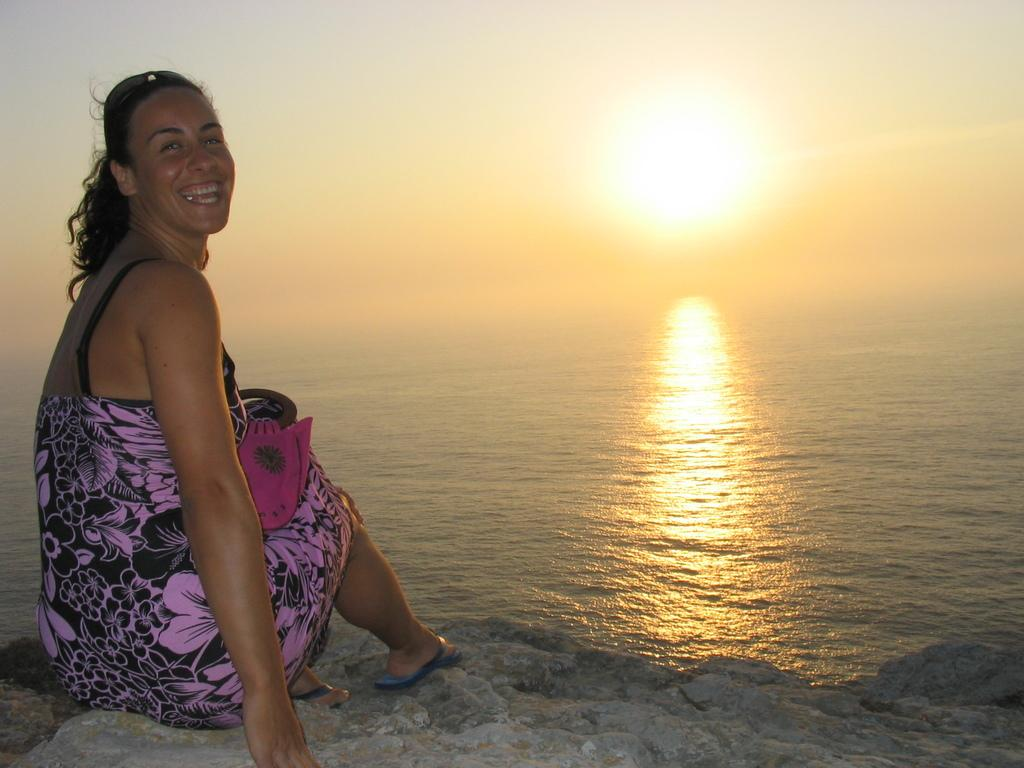Who is sitting on the left side of the image? There is a woman sitting on the left side of the image. What can be seen in the center of the image? There is water in the center of the image. What is visible in the sky in the image? The sun is visible in the sky. What type of laborer can be seen working in the aftermath of the storm in the image? There is no laborer or storm present in the image; it features a woman sitting near water with the sun visible in the sky. 